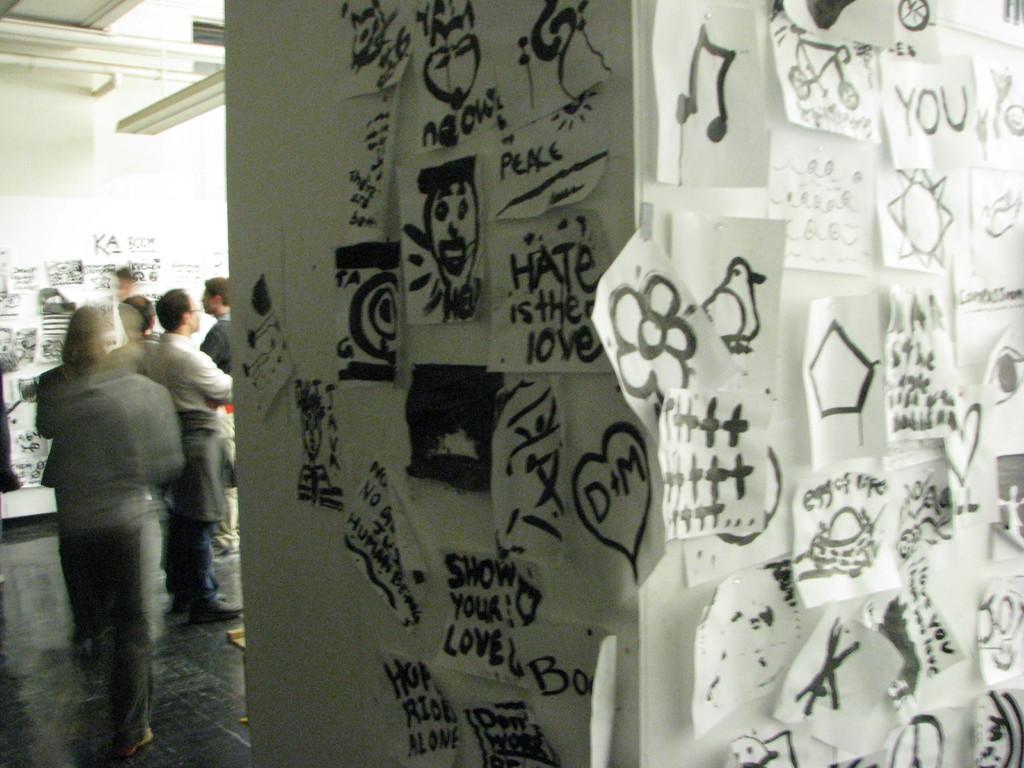Can you describe this image briefly? In this image we can see pictures pasted on the wall and persons standing on the floor. 